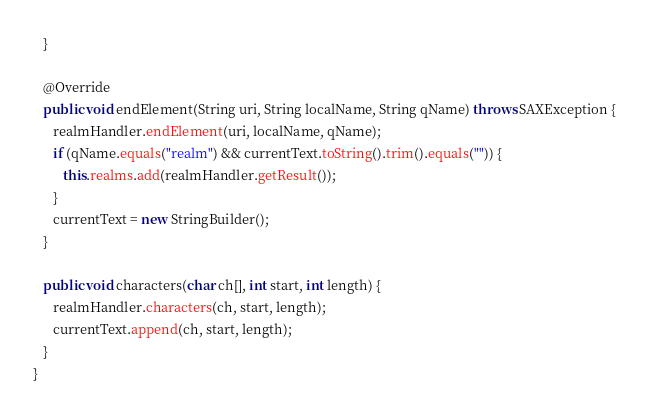<code> <loc_0><loc_0><loc_500><loc_500><_Java_>   }

   @Override
   public void endElement(String uri, String localName, String qName) throws SAXException {
      realmHandler.endElement(uri, localName, qName);
      if (qName.equals("realm") && currentText.toString().trim().equals("")) {
         this.realms.add(realmHandler.getResult());
      }
      currentText = new StringBuilder();
   }

   public void characters(char ch[], int start, int length) {
      realmHandler.characters(ch, start, length);
      currentText.append(ch, start, length);
   }
}
</code> 